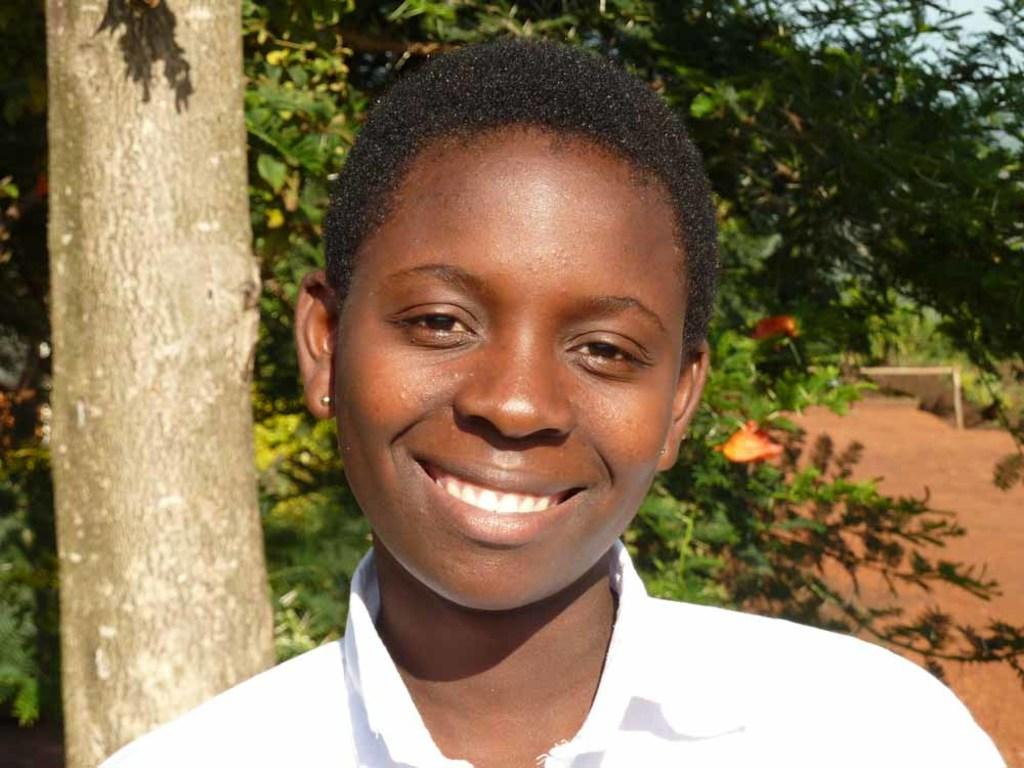Who is present in the image? There is a person in the image. What is the person wearing? The person is wearing a white shirt. Where is the person located in the image? The person is standing in the foreground of the image. What can be seen in the background of the image? There are trees in the background of the image. What type of pear is the person holding in the image? There is no pear present in the image; the person is not holding any fruit. 